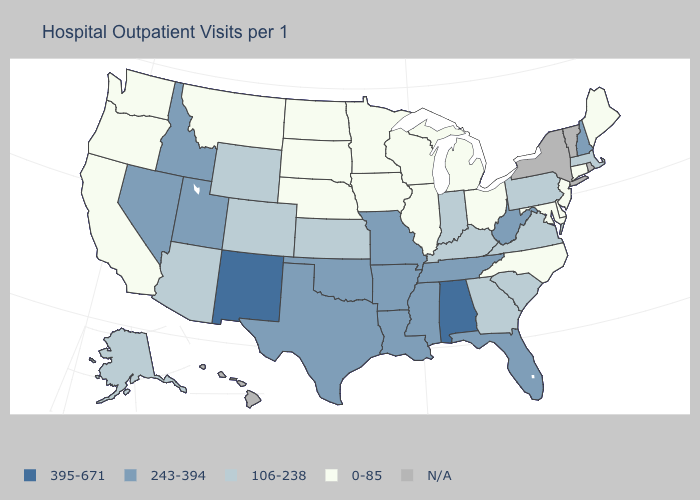Which states have the highest value in the USA?
Short answer required. Alabama, New Mexico. Name the states that have a value in the range 0-85?
Be succinct. California, Connecticut, Delaware, Illinois, Iowa, Maine, Maryland, Michigan, Minnesota, Montana, Nebraska, New Jersey, North Carolina, North Dakota, Ohio, Oregon, South Dakota, Washington, Wisconsin. Name the states that have a value in the range N/A?
Give a very brief answer. Hawaii, New York, Rhode Island, Vermont. What is the highest value in the USA?
Keep it brief. 395-671. Does the first symbol in the legend represent the smallest category?
Quick response, please. No. What is the value of Alabama?
Write a very short answer. 395-671. What is the value of Maine?
Give a very brief answer. 0-85. Does Maryland have the lowest value in the South?
Quick response, please. Yes. Does New Mexico have the highest value in the West?
Concise answer only. Yes. What is the value of Massachusetts?
Keep it brief. 106-238. Does Oklahoma have the lowest value in the USA?
Short answer required. No. Name the states that have a value in the range N/A?
Be succinct. Hawaii, New York, Rhode Island, Vermont. Among the states that border Virginia , which have the lowest value?
Keep it brief. Maryland, North Carolina. Does North Carolina have the lowest value in the South?
Short answer required. Yes. Name the states that have a value in the range 106-238?
Write a very short answer. Alaska, Arizona, Colorado, Georgia, Indiana, Kansas, Kentucky, Massachusetts, Pennsylvania, South Carolina, Virginia, Wyoming. 